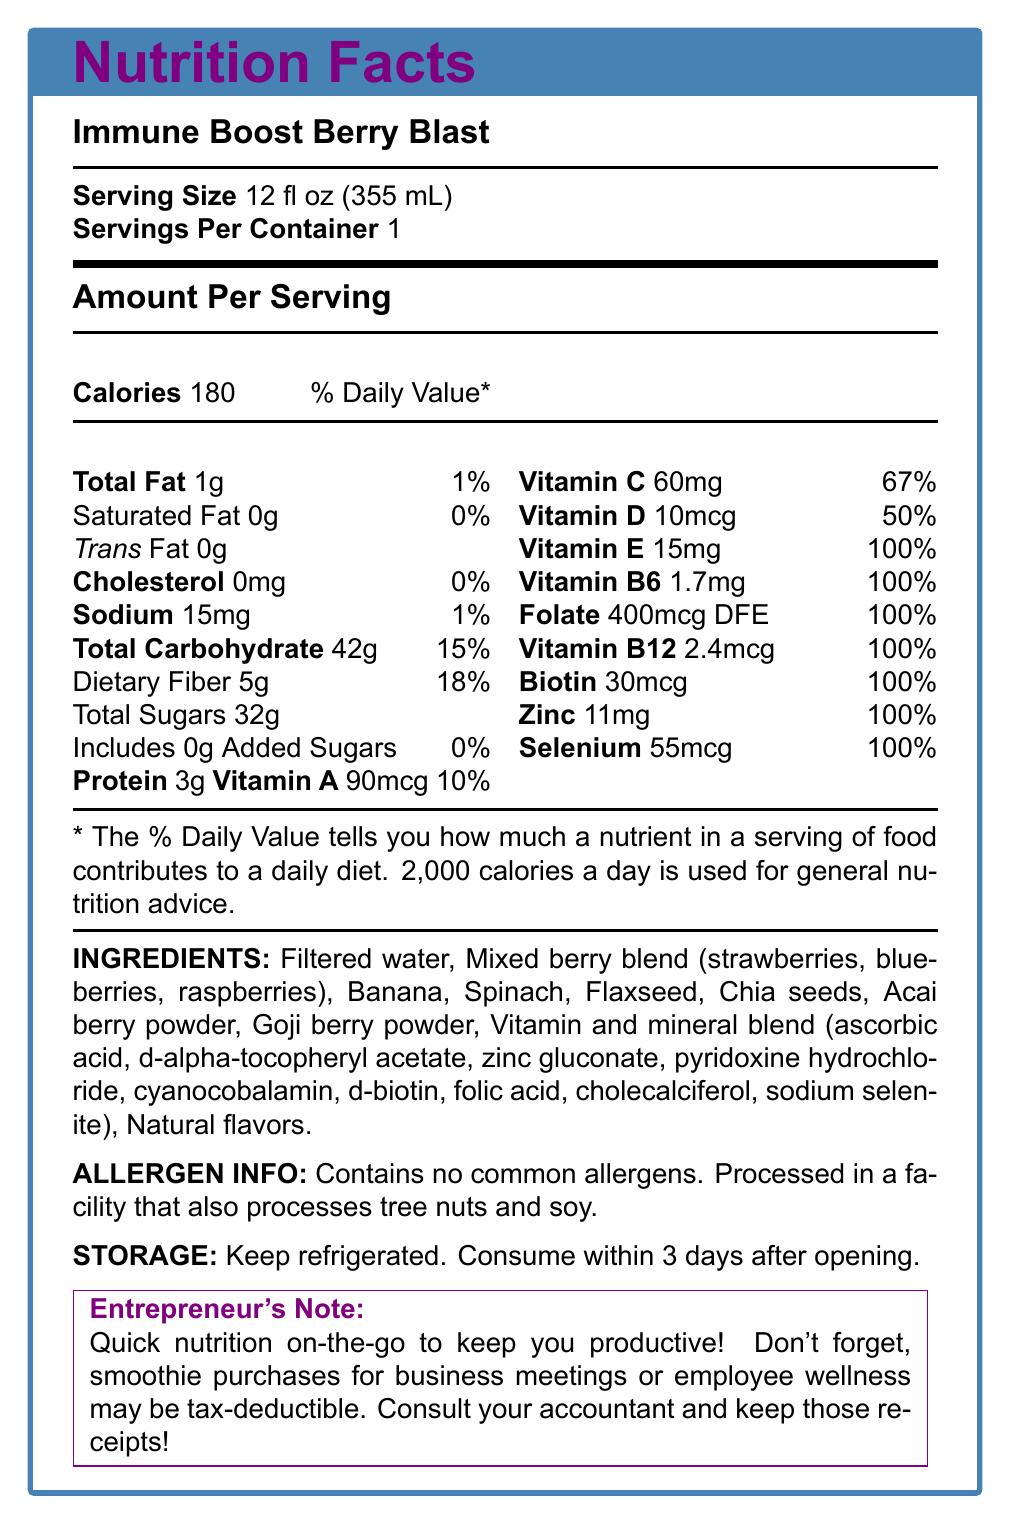what is the product name? The product name is clearly labeled at the top of the document.
Answer: Immune Boost Berry Blast what is the serving size of the Immune Boost Berry Blast smoothie? The serving size is stated as 12 fl oz (355 mL) near the beginning of the document.
Answer: 12 fl oz (355 mL) how many calories are in one serving of this smoothie? The amount per serving section lists 180 calories.
Answer: 180 how much dietary fiber is in one serving, and what percentage of the daily value does it provide? The nutritional information states that there are 5g of dietary fiber, which is 18% of the daily value.
Answer: 5g, 18% what is the amount of vitamin C in one serving? The vitamin C content is listed as 60mg per serving.
Answer: 60mg how many added sugars does this smoothie contain? The document shows that total sugars are 32g, but added sugars are 0g.
Answer: 0g what are the total carbohydrates and their daily value percentage in this smoothie? The total carbohydrate amount is 42g, which is 15% of the daily value.
Answer: 42g, 15% which of the following vitamins are provided at 100% daily value in this smoothie? A. Vitamin A B. Vitamin B6 C. Vitamin C D. Vitamin E Vitamin B6 is listed at 100% DV, whereas Vitamin A is 10%, Vitamin C is 67%, and Vitamin E is 100%.
Answer: B. Vitamin B6 which nutrient is present in the highest daily value percentage? A. Vitamin A B. Vitamin C C. Vitamin E D. Sodium E. Zinc Vitamin E is provided at 100% daily value, the highest among the options given.
Answer: C. Vitamin E is this product allergen-free? The allergen information states that it contains no common allergens but is processed in a facility that processes tree nuts and soy.
Answer: No does this smoothie support immune health? The product benefits section lists "Supports immune system health" as one of the benefits.
Answer: Yes is the Immune Boost Berry Blast suitable for those with nut allergies? Although it contains no common allergens, it is processed in a facility that also processes tree nuts, which could be a risk for people with nut allergies.
Answer: Not Recommended summarize the main purpose and benefits of the Immune Boost Berry Blast smoothie. The document highlights the nutritional benefits of the smoothie, its immune support capabilities, and its convenience for a busy entrepreneur.
Answer: This smoothie provides immune support and is nutrient-rich with antioxidants and essential vitamins and minerals. It offers convenient nutrition for busy lifestyles without added sugars and common allergens. what are the ingredients of the smoothie that help with its antioxidant properties? These ingredients are known for their high antioxidant content.
Answer: Mixed berry blend (strawberries, blueberries, raspberries), Acai berry powder, Goji berry powder can this smoothie be purchased for business meetings as a tax-deductible expense? The note at the end mentions that smoothie purchases for business meetings or employee wellness programs may be tax-deductible.
Answer: Yes what is the recommended storage instruction for the smoothie once opened? The storage instructions clearly state to keep it refrigerated and consume within 3 days after opening.
Answer: Keep refrigerated. Consume within 3 days after opening. how does the product benefit someone with a busy lifestyle? The entrepreneur benefits section explains how the smoothie fits the needs of a busy entrepreneur by providing easy, convenient nutrition.
Answer: Quick and easy nutrition on-the-go, helps maintain energy levels, supports overall health, and has a long shelf life. what are the health benefits listed for the Immune Boost Berry Blast smoothie? The product benefits section outlines these specific health benefits.
Answer: Supports immune system health, rich in antioxidants, no added sugars, good source of fiber, provides 100% daily value of 7 essential vitamins and minerals what percentage of the daily value of protein does this smoothie provide? The document lists 3g of protein but does not specify a % daily value for protein.
Answer: Cannot be determined what type of facility is this product processed in? The allergen information specifies that it is processed in a facility that also processes tree nuts and soy.
Answer: Facility that also processes tree nuts and soy 